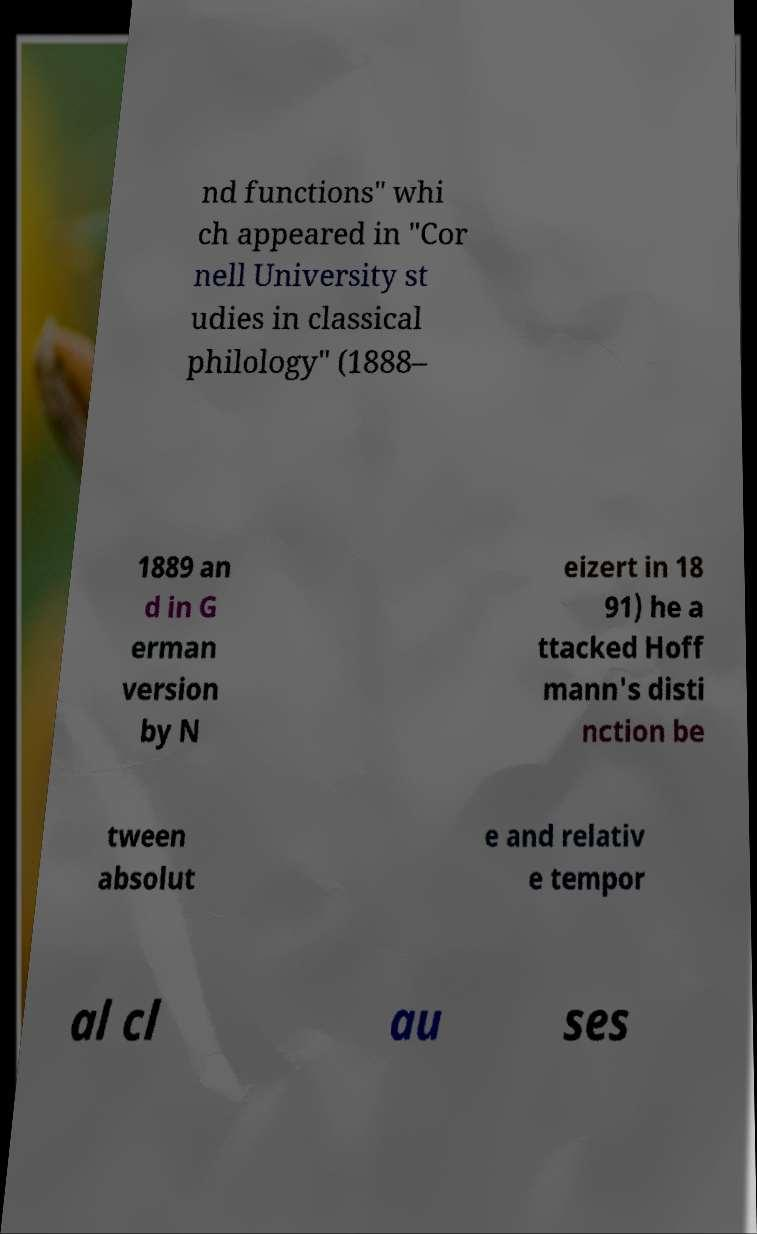Please read and relay the text visible in this image. What does it say? nd functions" whi ch appeared in "Cor nell University st udies in classical philology" (1888– 1889 an d in G erman version by N eizert in 18 91) he a ttacked Hoff mann's disti nction be tween absolut e and relativ e tempor al cl au ses 